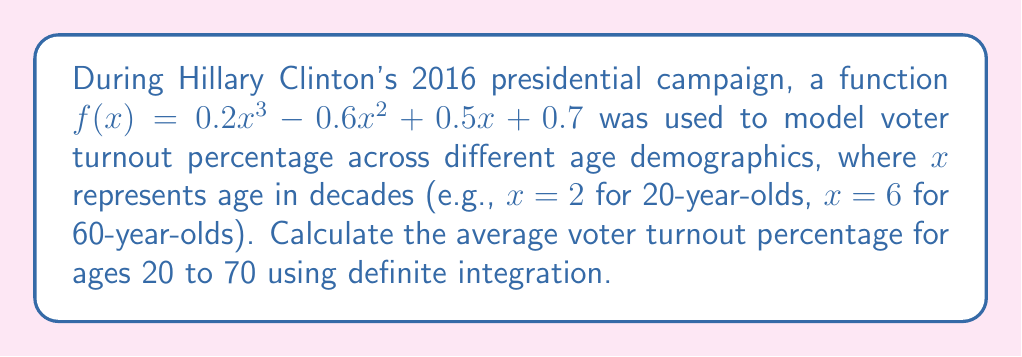What is the answer to this math problem? To find the average voter turnout percentage, we need to:
1. Set up the definite integral of $f(x)$ from $x=2$ to $x=7$
2. Calculate the area under the curve
3. Divide the result by the interval length (7 - 2 = 5)

Step 1: Set up the definite integral
$$\frac{1}{5}\int_{2}^{7} (0.2x^3 - 0.6x^2 + 0.5x + 0.7) dx$$

Step 2: Integrate the function
$$\frac{1}{5} \left[ 0.05x^4 - 0.2x^3 + 0.25x^2 + 0.7x \right]_{2}^{7}$$

Step 3: Evaluate the integral
$$\frac{1}{5} \left[ (0.05(7^4) - 0.2(7^3) + 0.25(7^2) + 0.7(7)) - (0.05(2^4) - 0.2(2^3) + 0.25(2^2) + 0.7(2)) \right]$$
$$\frac{1}{5} \left[ (85.75 - 68.6 + 12.25 + 4.9) - (0.8 - 1.6 + 1 + 1.4) \right]$$
$$\frac{1}{5} \left[ 34.3 - 1.6 \right] = \frac{32.7}{5} = 6.54$$

Therefore, the average voter turnout percentage for ages 20 to 70 is 6.54%.
Answer: 6.54% 